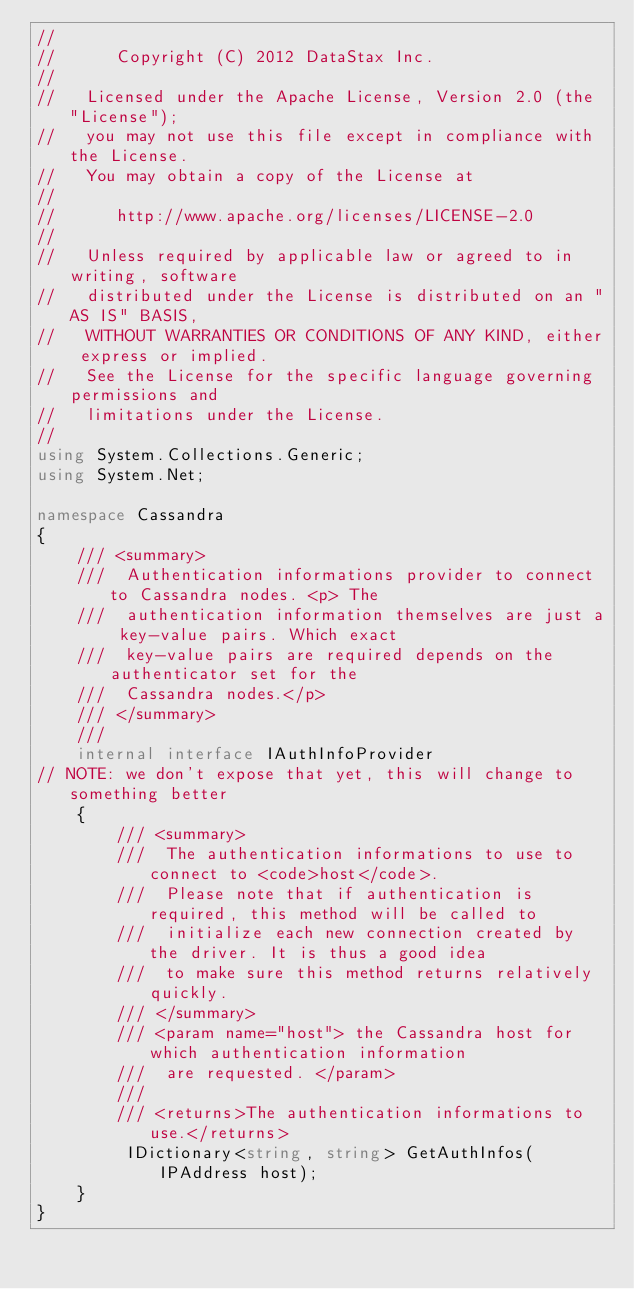<code> <loc_0><loc_0><loc_500><loc_500><_C#_>//
//      Copyright (C) 2012 DataStax Inc.
//
//   Licensed under the Apache License, Version 2.0 (the "License");
//   you may not use this file except in compliance with the License.
//   You may obtain a copy of the License at
//
//      http://www.apache.org/licenses/LICENSE-2.0
//
//   Unless required by applicable law or agreed to in writing, software
//   distributed under the License is distributed on an "AS IS" BASIS,
//   WITHOUT WARRANTIES OR CONDITIONS OF ANY KIND, either express or implied.
//   See the License for the specific language governing permissions and
//   limitations under the License.
//
using System.Collections.Generic;
using System.Net;

namespace Cassandra
{
    /// <summary>
    ///  Authentication informations provider to connect to Cassandra nodes. <p> The
    ///  authentication information themselves are just a key-value pairs. Which exact
    ///  key-value pairs are required depends on the authenticator set for the
    ///  Cassandra nodes.</p>
    /// </summary>
    /// 
    internal interface IAuthInfoProvider
// NOTE: we don't expose that yet, this will change to something better
    {
        /// <summary>
        ///  The authentication informations to use to connect to <code>host</code>.
        ///  Please note that if authentication is required, this method will be called to
        ///  initialize each new connection created by the driver. It is thus a good idea
        ///  to make sure this method returns relatively quickly.
        /// </summary>
        /// <param name="host"> the Cassandra host for which authentication information
        ///  are requested. </param>
        /// 
        /// <returns>The authentication informations to use.</returns>
         IDictionary<string, string> GetAuthInfos(IPAddress host);
    }
}
</code> 